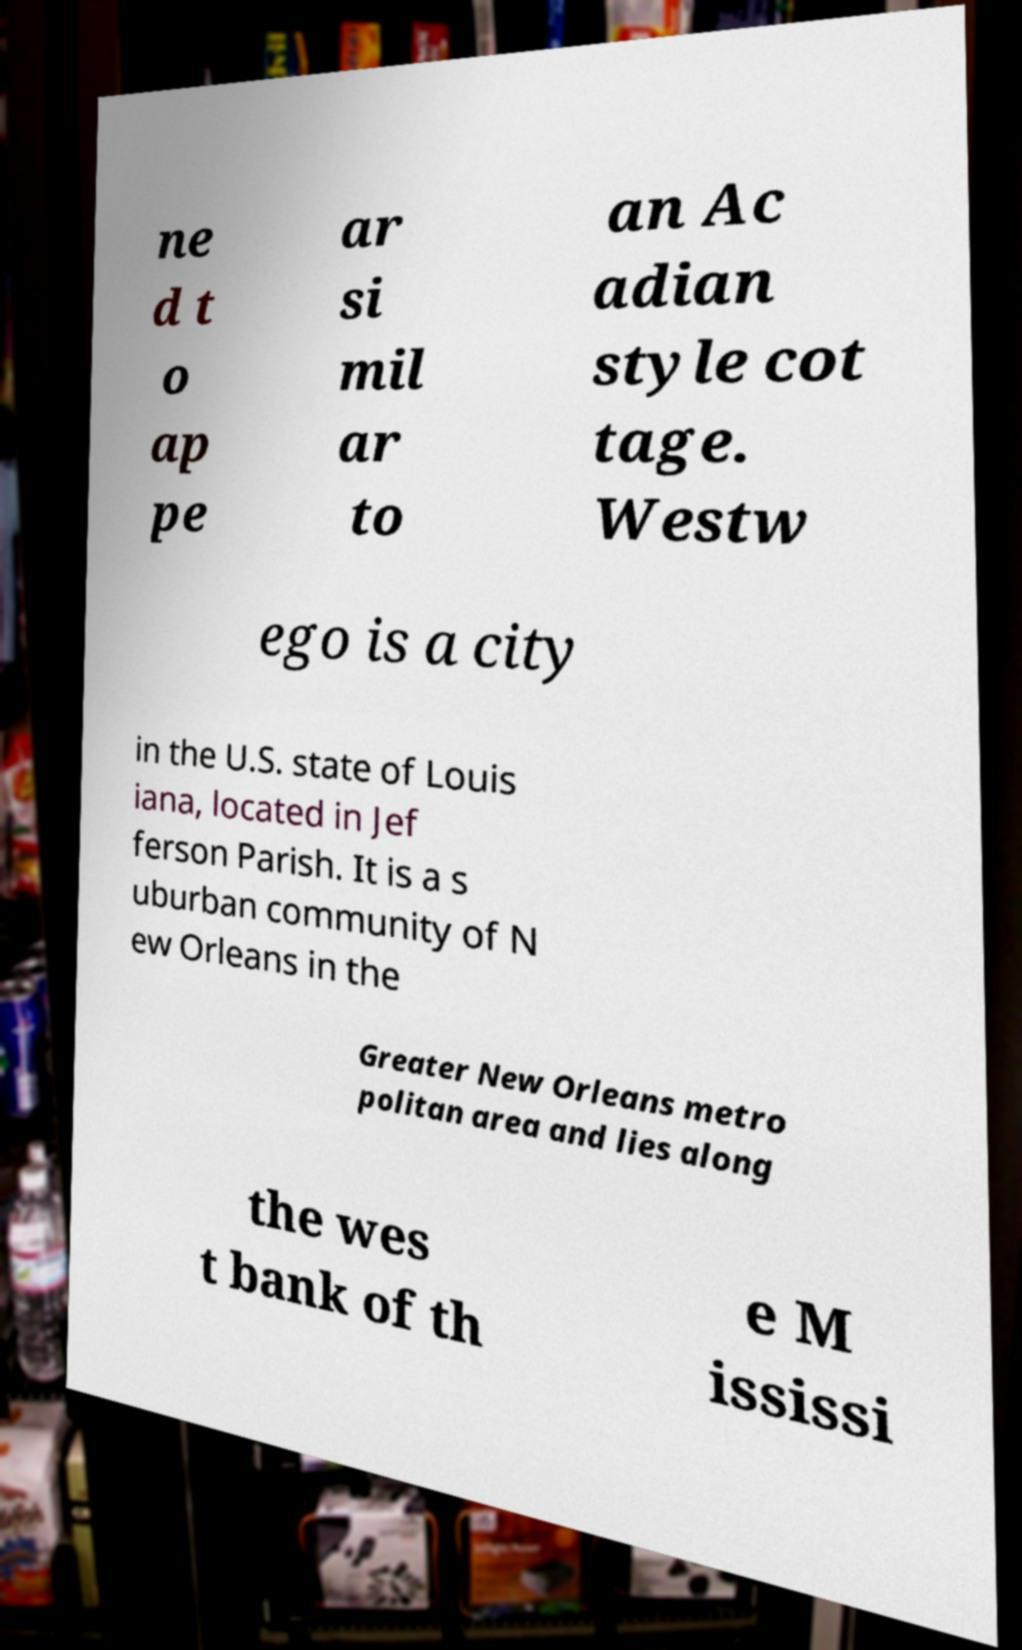Can you accurately transcribe the text from the provided image for me? ne d t o ap pe ar si mil ar to an Ac adian style cot tage. Westw ego is a city in the U.S. state of Louis iana, located in Jef ferson Parish. It is a s uburban community of N ew Orleans in the Greater New Orleans metro politan area and lies along the wes t bank of th e M ississi 